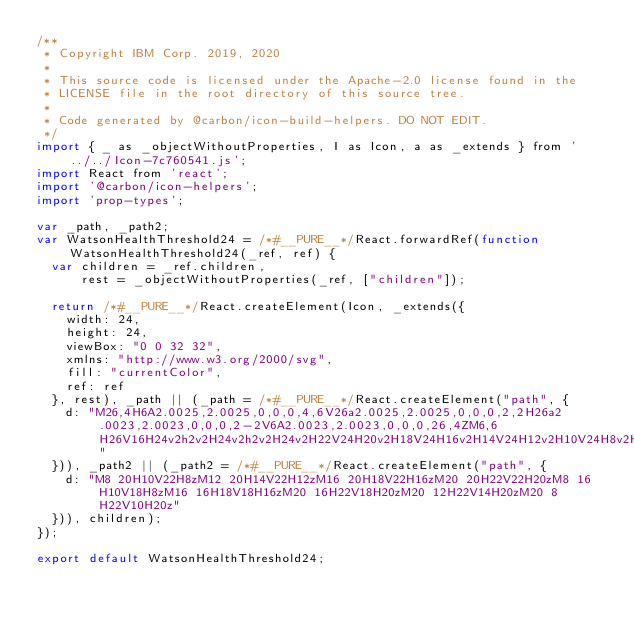Convert code to text. <code><loc_0><loc_0><loc_500><loc_500><_JavaScript_>/**
 * Copyright IBM Corp. 2019, 2020
 *
 * This source code is licensed under the Apache-2.0 license found in the
 * LICENSE file in the root directory of this source tree.
 *
 * Code generated by @carbon/icon-build-helpers. DO NOT EDIT.
 */
import { _ as _objectWithoutProperties, I as Icon, a as _extends } from '../../Icon-7c760541.js';
import React from 'react';
import '@carbon/icon-helpers';
import 'prop-types';

var _path, _path2;
var WatsonHealthThreshold24 = /*#__PURE__*/React.forwardRef(function WatsonHealthThreshold24(_ref, ref) {
  var children = _ref.children,
      rest = _objectWithoutProperties(_ref, ["children"]);

  return /*#__PURE__*/React.createElement(Icon, _extends({
    width: 24,
    height: 24,
    viewBox: "0 0 32 32",
    xmlns: "http://www.w3.org/2000/svg",
    fill: "currentColor",
    ref: ref
  }, rest), _path || (_path = /*#__PURE__*/React.createElement("path", {
    d: "M26,4H6A2.0025,2.0025,0,0,0,4,6V26a2.0025,2.0025,0,0,0,2,2H26a2.0023,2.0023,0,0,0,2-2V6A2.0023,2.0023,0,0,0,26,4ZM6,6H26V16H24v2h2v2H24v2h2v2H24v2H22V24H20v2H18V24H16v2H14V24H12v2H10V24H8v2H6Z"
  })), _path2 || (_path2 = /*#__PURE__*/React.createElement("path", {
    d: "M8 20H10V22H8zM12 20H14V22H12zM16 20H18V22H16zM20 20H22V22H20zM8 16H10V18H8zM16 16H18V18H16zM20 16H22V18H20zM20 12H22V14H20zM20 8H22V10H20z"
  })), children);
});

export default WatsonHealthThreshold24;
</code> 